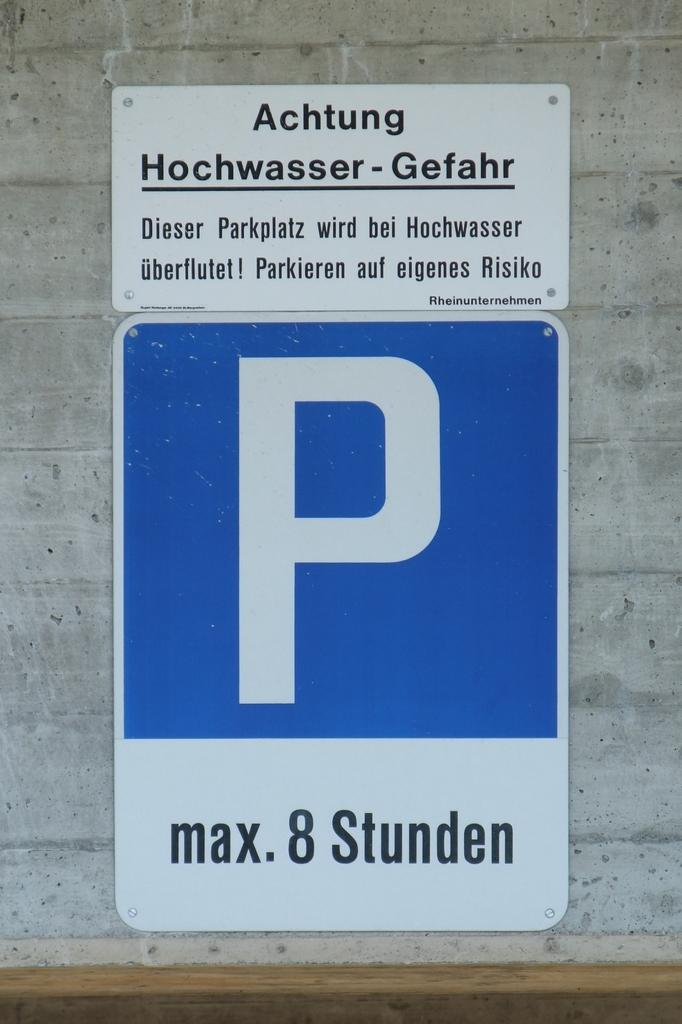<image>
Create a compact narrative representing the image presented. a parking sign with the letter P on it 